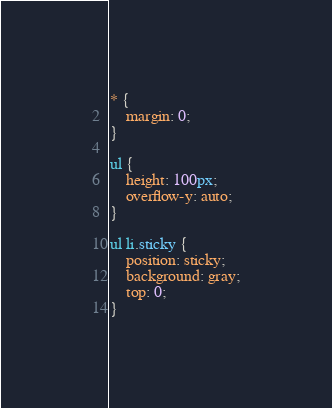<code> <loc_0><loc_0><loc_500><loc_500><_CSS_>* {
    margin: 0;
}

ul {
    height: 100px;
    overflow-y: auto;
}

ul li.sticky {
    position: sticky;
    background: gray;
    top: 0; 
}</code> 